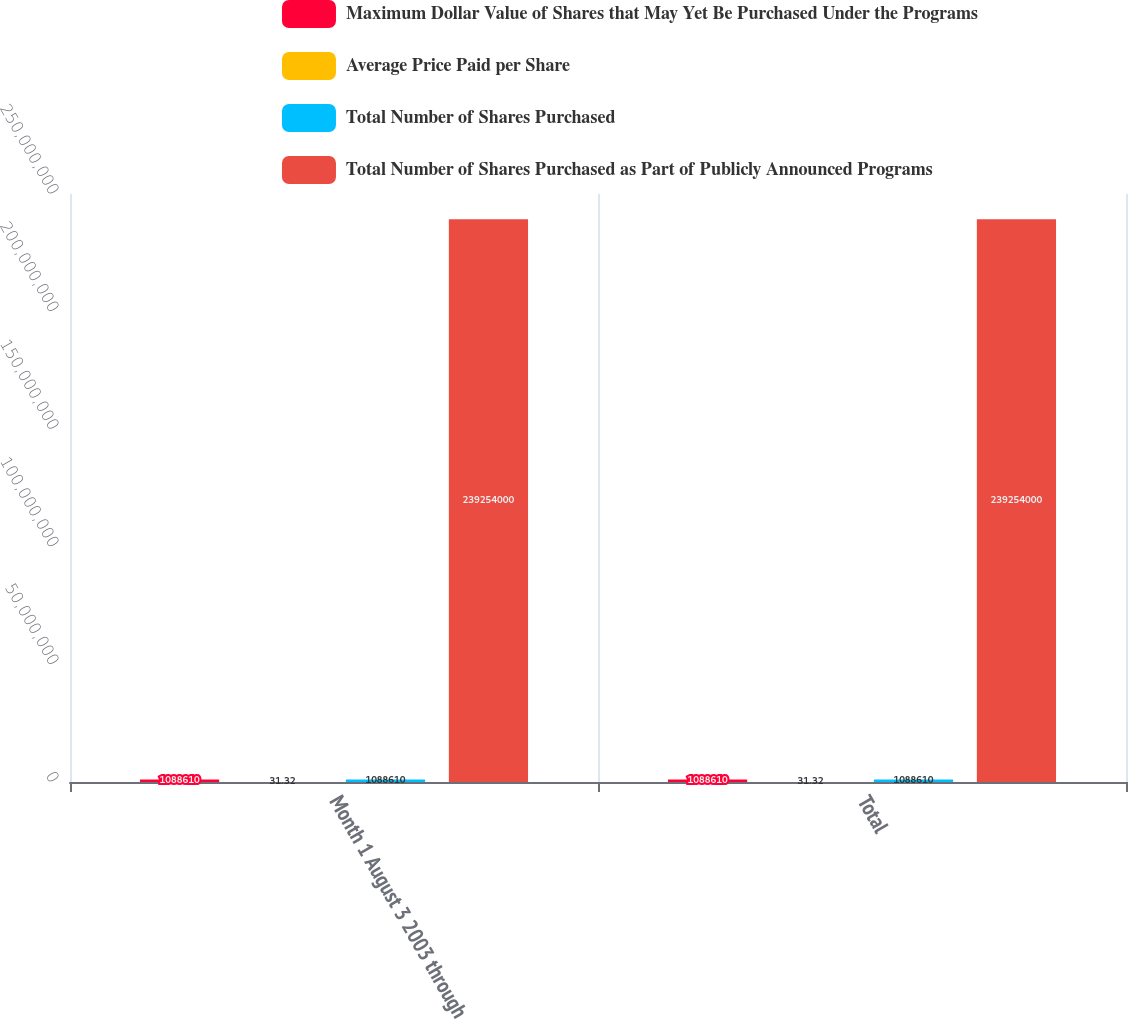<chart> <loc_0><loc_0><loc_500><loc_500><stacked_bar_chart><ecel><fcel>Month 1 August 3 2003 through<fcel>Total<nl><fcel>Maximum Dollar Value of Shares that May Yet Be Purchased Under the Programs<fcel>1.08861e+06<fcel>1.08861e+06<nl><fcel>Average Price Paid per Share<fcel>31.32<fcel>31.32<nl><fcel>Total Number of Shares Purchased<fcel>1.08861e+06<fcel>1.08861e+06<nl><fcel>Total Number of Shares Purchased as Part of Publicly Announced Programs<fcel>2.39254e+08<fcel>2.39254e+08<nl></chart> 